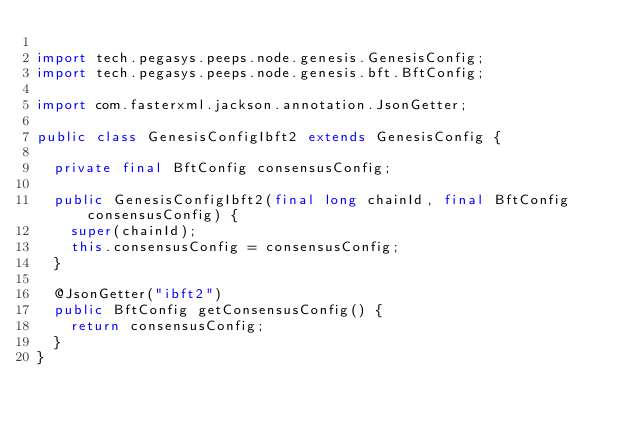<code> <loc_0><loc_0><loc_500><loc_500><_Java_>
import tech.pegasys.peeps.node.genesis.GenesisConfig;
import tech.pegasys.peeps.node.genesis.bft.BftConfig;

import com.fasterxml.jackson.annotation.JsonGetter;

public class GenesisConfigIbft2 extends GenesisConfig {

  private final BftConfig consensusConfig;

  public GenesisConfigIbft2(final long chainId, final BftConfig consensusConfig) {
    super(chainId);
    this.consensusConfig = consensusConfig;
  }

  @JsonGetter("ibft2")
  public BftConfig getConsensusConfig() {
    return consensusConfig;
  }
}
</code> 